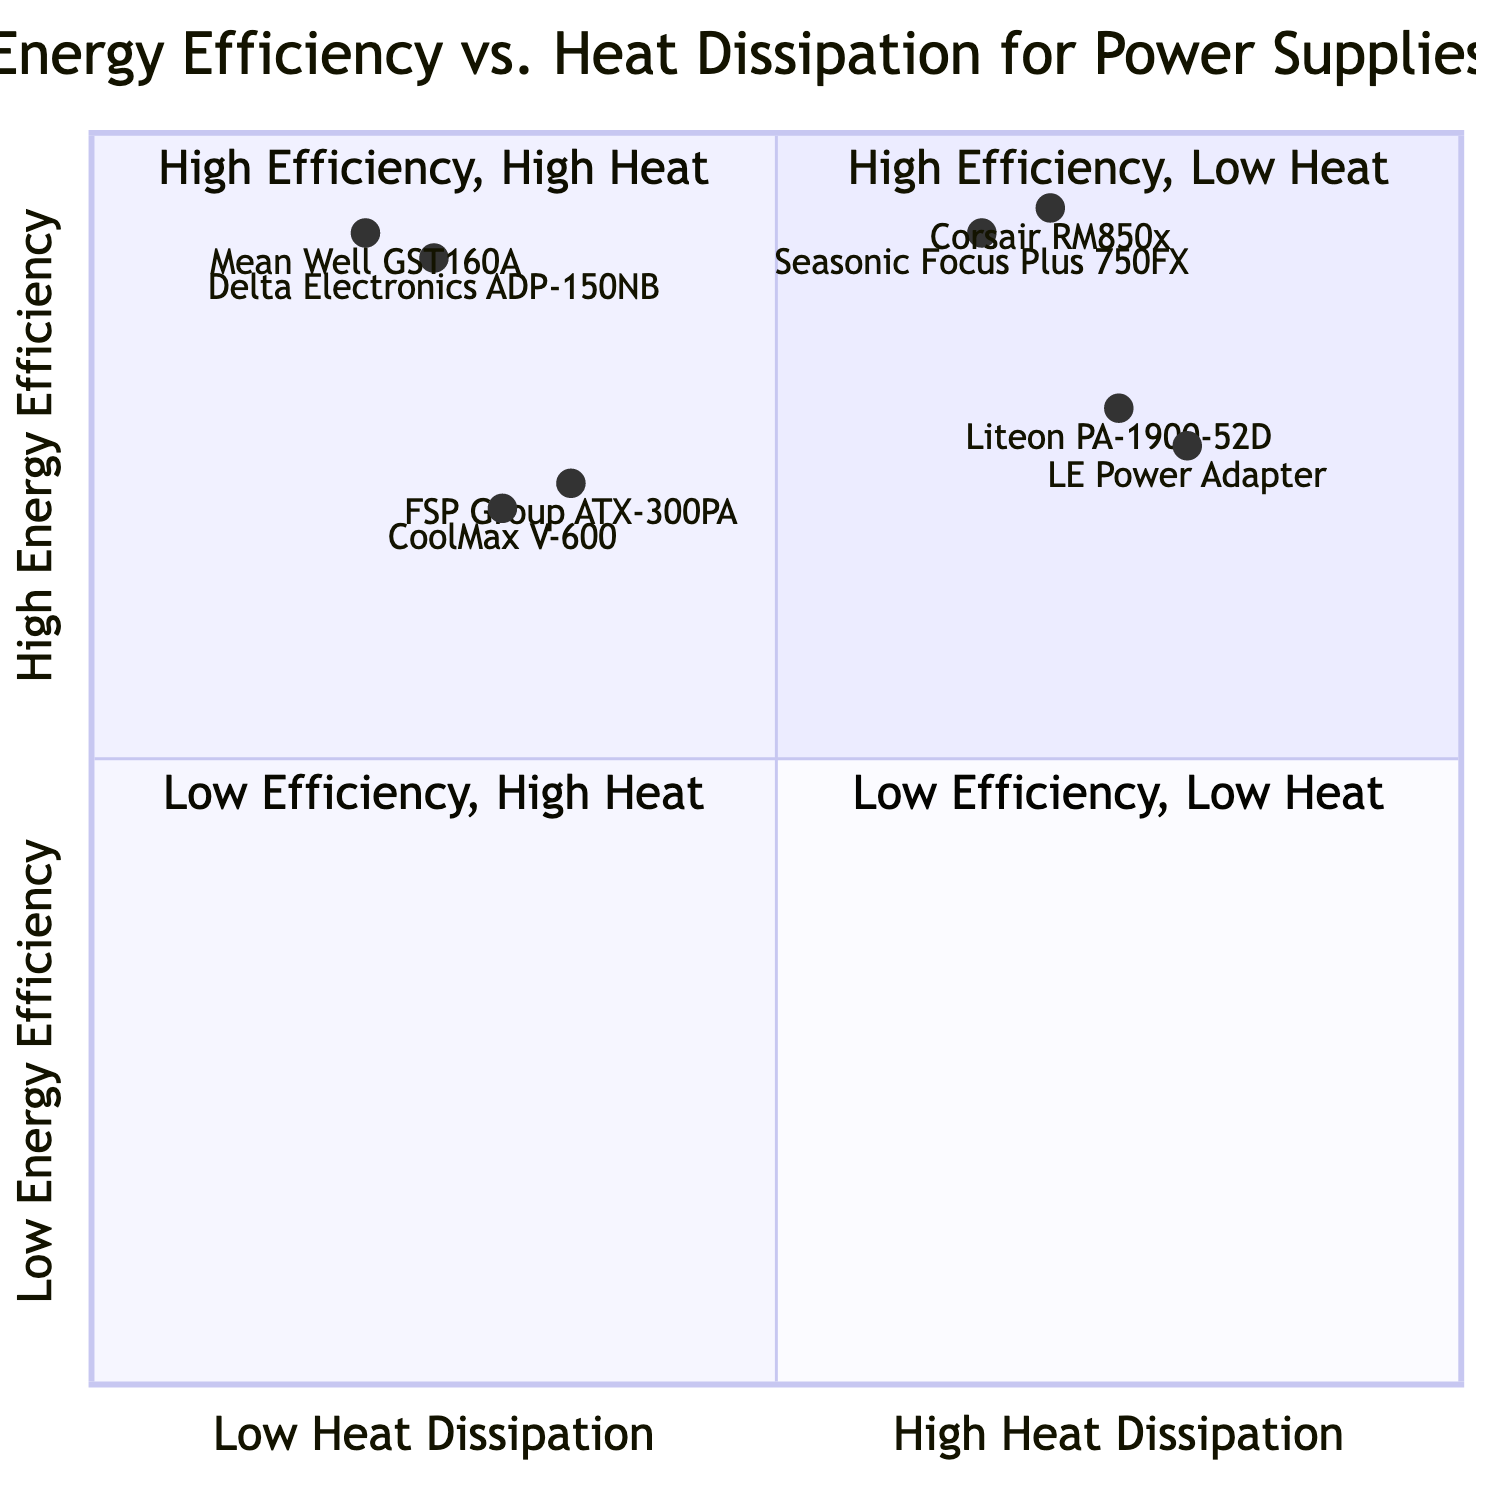What is the energy efficiency of the Mean Well GST160A? The Mean Well GST160A is located in the "High Energy Efficiency & Low Heat Dissipation" quadrant, which states it has an energy efficiency of 92%.
Answer: 92% Which power supply has the shortest lifespan? Among the examples listed, the LE Power Adapter in the "Low Energy Efficiency & High Heat Dissipation" quadrant is noted to have a short lifespan.
Answer: LE Power Adapter How many power supplies fall under the "Low Energy Efficiency & Low Heat Dissipation" category? There are two power supplies mentioned: CoolMax V-600 and FSP Group ATX-300PA, both categorized under "Low Energy Efficiency & Low Heat Dissipation."
Answer: 2 What is the cost of the Seasonic Focus Plus 750FX? The Seasonic Focus Plus 750FX is placed in the "High Energy Efficiency & High Heat Dissipation" quadrant, and it is associated with a high cost.
Answer: High Which power supply would be most effective in terms of energy savings? The Mean Well GST160A in the "High Energy Efficiency & Low Heat Dissipation" quadrant, with its combination of high energy efficiency and low heat dissipation, would lead to significant cost savings over time.
Answer: Mean Well GST160A What is the heat dissipation level of the Liteon PA-1900-52D? The Liteon PA-1900-52D is located in the "Low Energy Efficiency & High Heat Dissipation" quadrant, which indicates it has a high heat dissipation level.
Answer: High Which quadrant contains the most efficient power supply? The "High Energy Efficiency & Low Heat Dissipation" quadrant contains the most efficient power supply, as both the Mean Well GST160A and Delta Electronics ADP-150NB have high energy efficiencies of 92% and 90%, respectively.
Answer: High Energy Efficiency & Low Heat Dissipation Which power supply is the least efficient? The CoolMax V-600 has the lowest energy efficiency at 70%, placing it in the "Low Energy Efficiency & Low Heat Dissipation" quadrant.
Answer: CoolMax V-600 What relationship exists between energy efficiency and heat dissipation in power supplies? The diagram illustrates that generally, high energy efficiency correlates with low heat dissipation, and low energy efficiency tends to correspond with high heat dissipation, particularly visible in the arranged quadrants.
Answer: Inverse relationship 